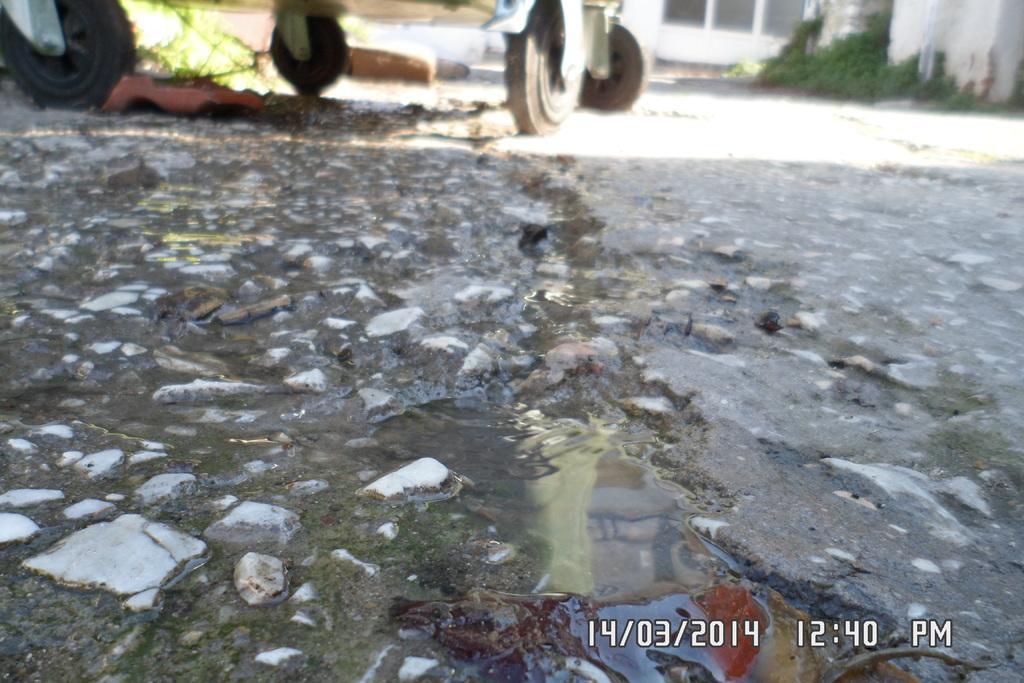In one or two sentences, can you explain what this image depicts? In this image there is a floor on that floor there is water in the background there is a wheel tray, at the bottom there is time and date. 